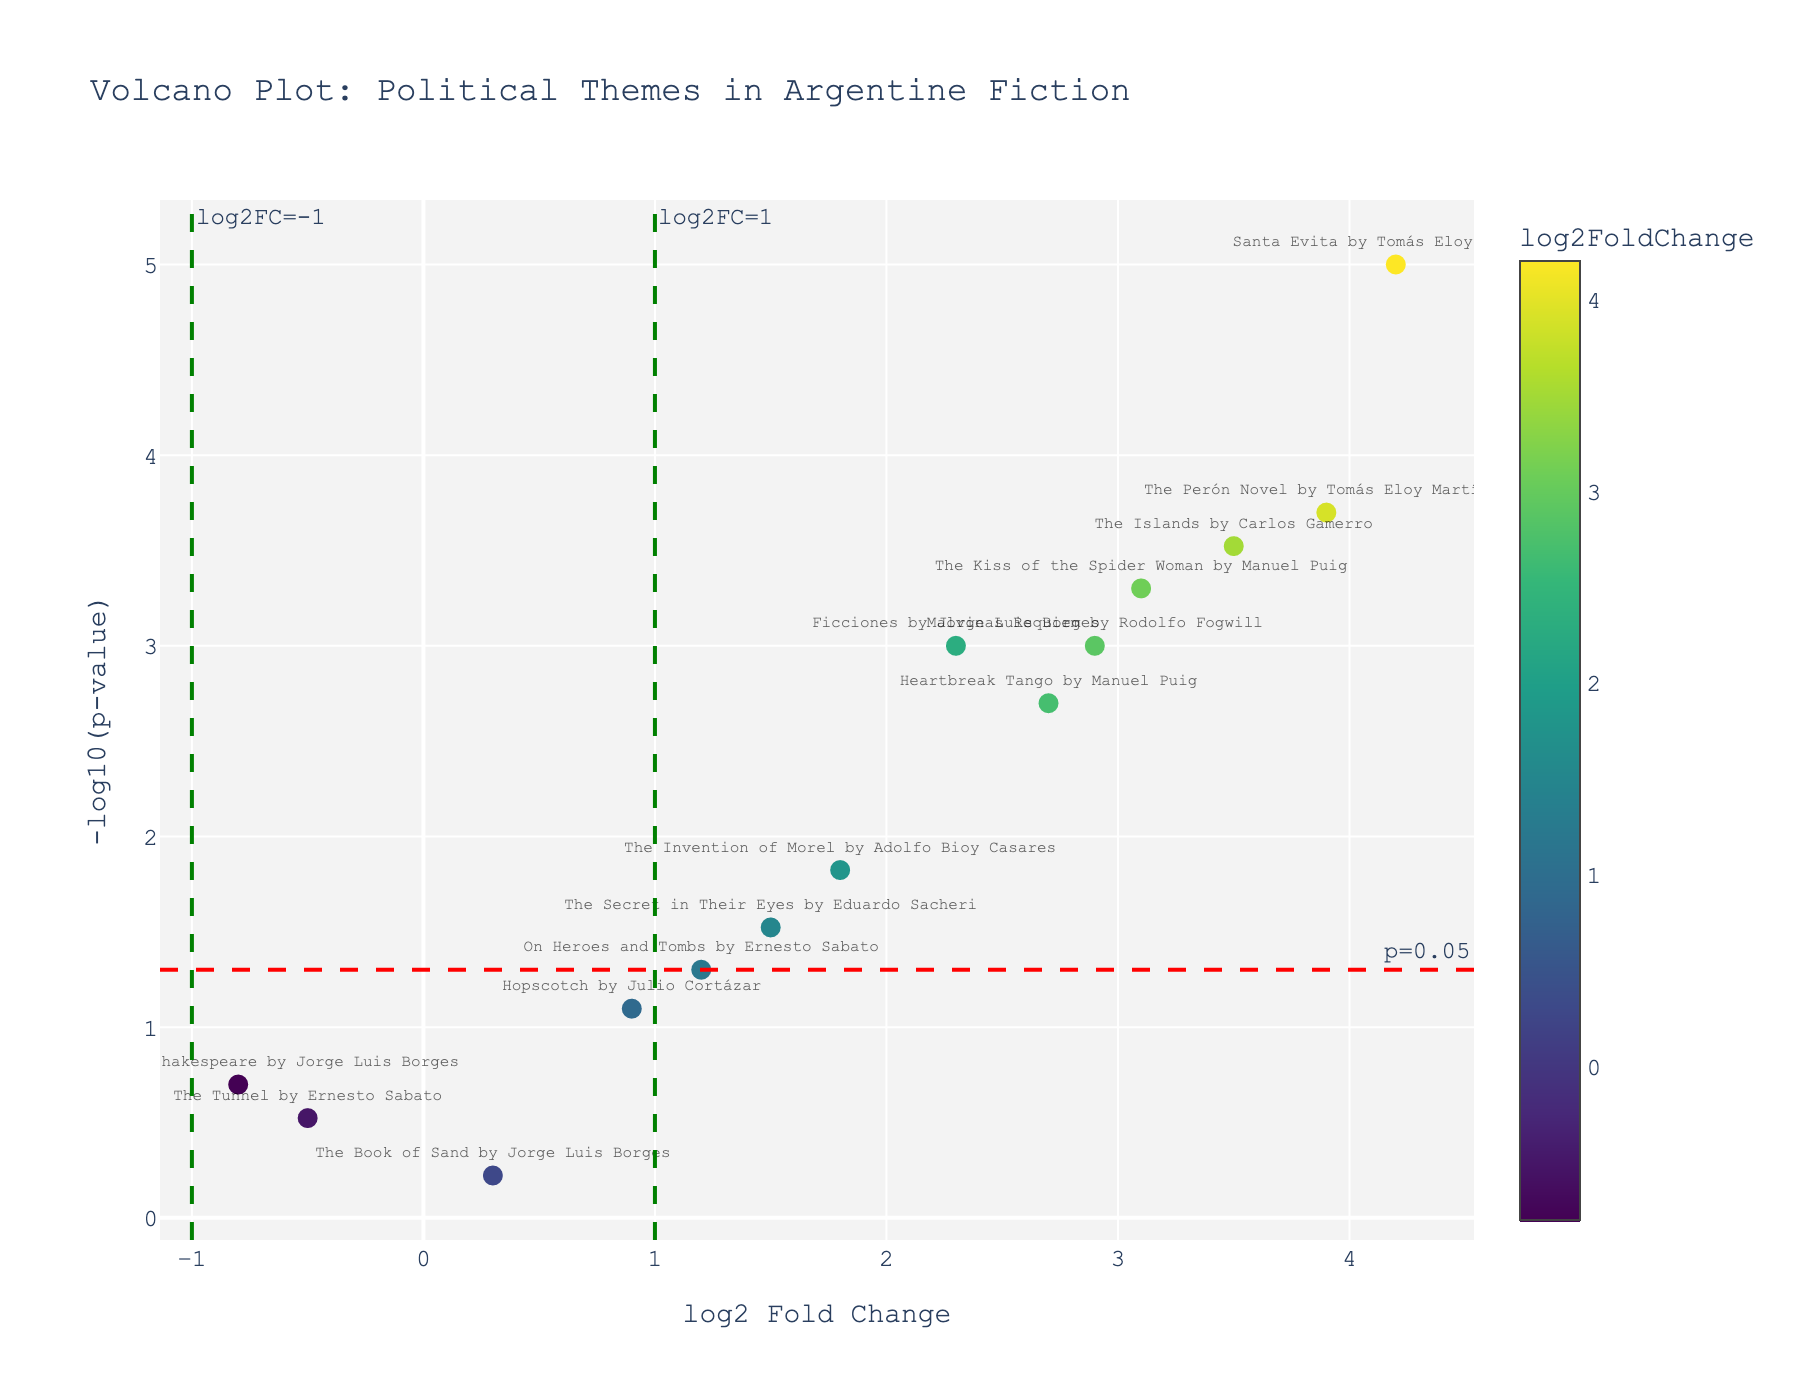What is the title of the plot? The title of the plot is displayed at the top of the figure in a larger and bold font.
Answer: Volcano Plot: Political Themes in Argentine Fiction What are the x-axis and y-axis titles? The x-axis title is "log2 Fold Change" and the y-axis title is "-log10(p-value)". These titles are placed along their respective axes.
Answer: log2 Fold Change, -log10(p-value) Which novel has the highest log2 Fold Change? The novel with the highest log2 Fold Change is the data point farthest to the right on the x-axis.
Answer: "Santa Evita" by Tomás Eloy Martínez How many data points have a p-value less than 0.05? Data points with a p-value less than 0.05 are above the horizontal red dashed line. Count the points above this threshold line.
Answer: 9 What is the log2 Fold Change and p-value for "The Kiss of the Spider Woman"? Find "The Kiss of the Spider Woman" on the plot and check the hover information or the position coordinates.
Answer: log2FoldChange: 3.1, p-value: 0.0005 Which novel has the lowest log2 Fold Change and what is its approximate p-value? The novel with the lowest log2 Fold Change is the data point farthest to the left on the x-axis. Identify this point and check its y-axis value.
Answer: "The Tunnel" by Ernesto Sabato, approximately 0.3 Compare the log2 Fold Change between "Ficciones" and "The Memory of Shakespeare". Which one is higher? "Ficciones" by Jorge Luis Borges has a log2 Fold Change of 2.3, while "The Memory of Shakespeare" by Jorge Luis Borges has a log2 Fold Change of -0.8. Since 2.3 is higher than -0.8, "Ficciones" has the higher log2 Fold Change.
Answer: "Ficciones" by Jorge Luis Borges How many novels have both log2 Fold Change greater than 2 and p-value less than 0.05? Check for data points that are right of the vertical green dashed line at log2FC=1 and above the horizontal red dashed line at p-value=0.05. Count these points.
Answer: 7 What conclusion can be drawn from "Santa Evita" about the significance and impact of political themes? "Santa Evita" has the highest log2 Fold Change indicating a strong presence of political themes and a very low p-value suggesting statistical significance. This means "Santa Evita" contains significant and impactful political themes.
Answer: Strong presence and highly significant 